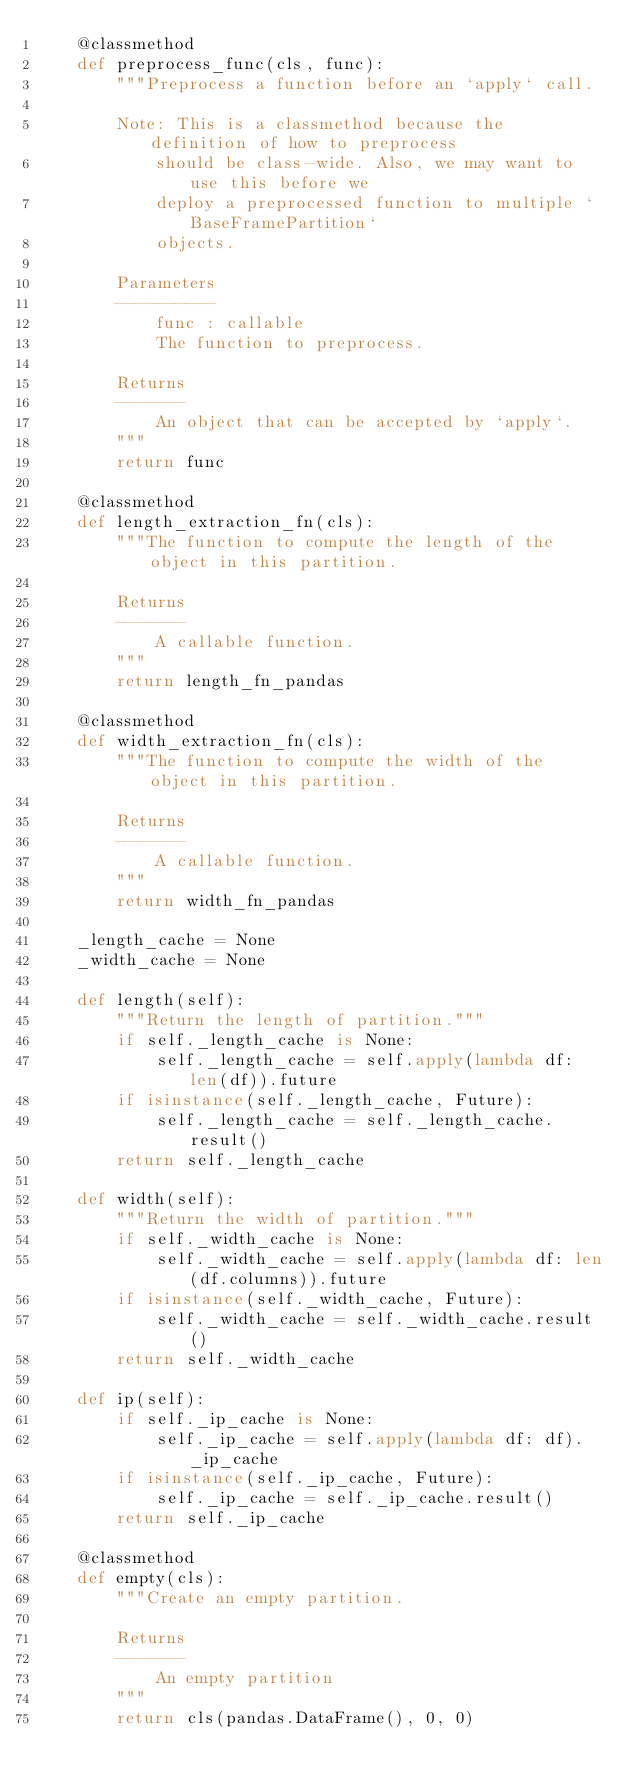<code> <loc_0><loc_0><loc_500><loc_500><_Python_>    @classmethod
    def preprocess_func(cls, func):
        """Preprocess a function before an `apply` call.

        Note: This is a classmethod because the definition of how to preprocess
            should be class-wide. Also, we may want to use this before we
            deploy a preprocessed function to multiple `BaseFramePartition`
            objects.

        Parameters
        ----------
            func : callable
            The function to preprocess.

        Returns
        -------
            An object that can be accepted by `apply`.
        """
        return func

    @classmethod
    def length_extraction_fn(cls):
        """The function to compute the length of the object in this partition.

        Returns
        -------
            A callable function.
        """
        return length_fn_pandas

    @classmethod
    def width_extraction_fn(cls):
        """The function to compute the width of the object in this partition.

        Returns
        -------
            A callable function.
        """
        return width_fn_pandas

    _length_cache = None
    _width_cache = None

    def length(self):
        """Return the length of partition."""
        if self._length_cache is None:
            self._length_cache = self.apply(lambda df: len(df)).future
        if isinstance(self._length_cache, Future):
            self._length_cache = self._length_cache.result()
        return self._length_cache

    def width(self):
        """Return the width of partition."""
        if self._width_cache is None:
            self._width_cache = self.apply(lambda df: len(df.columns)).future
        if isinstance(self._width_cache, Future):
            self._width_cache = self._width_cache.result()
        return self._width_cache

    def ip(self):
        if self._ip_cache is None:
            self._ip_cache = self.apply(lambda df: df)._ip_cache
        if isinstance(self._ip_cache, Future):
            self._ip_cache = self._ip_cache.result()
        return self._ip_cache

    @classmethod
    def empty(cls):
        """Create an empty partition.

        Returns
        -------
            An empty partition
        """
        return cls(pandas.DataFrame(), 0, 0)
</code> 